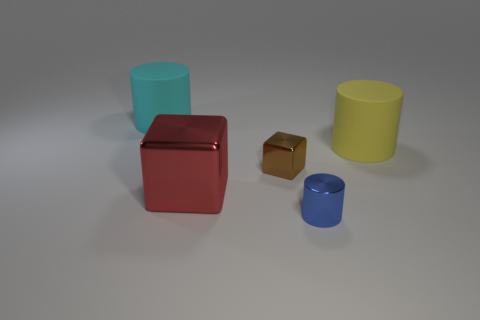What number of cyan rubber cylinders are the same size as the red metal thing?
Make the answer very short. 1. Does the matte cylinder that is in front of the large cyan matte object have the same size as the blue cylinder that is in front of the tiny brown metal object?
Your answer should be compact. No. What number of things are tiny brown objects or cylinders to the right of the big cyan matte cylinder?
Your response must be concise. 3. The tiny shiny block is what color?
Give a very brief answer. Brown. What material is the large thing that is right of the cylinder that is in front of the thing that is right of the metal cylinder?
Offer a very short reply. Rubber. What is the size of the brown block that is the same material as the tiny cylinder?
Make the answer very short. Small. Is there a metallic cylinder that has the same color as the large shiny block?
Ensure brevity in your answer.  No. Is the size of the cyan cylinder the same as the cube right of the red cube?
Offer a terse response. No. What number of rubber things are in front of the big object behind the matte object on the right side of the cyan matte thing?
Keep it short and to the point. 1. Are there any large yellow cylinders on the left side of the tiny blue thing?
Give a very brief answer. No. 